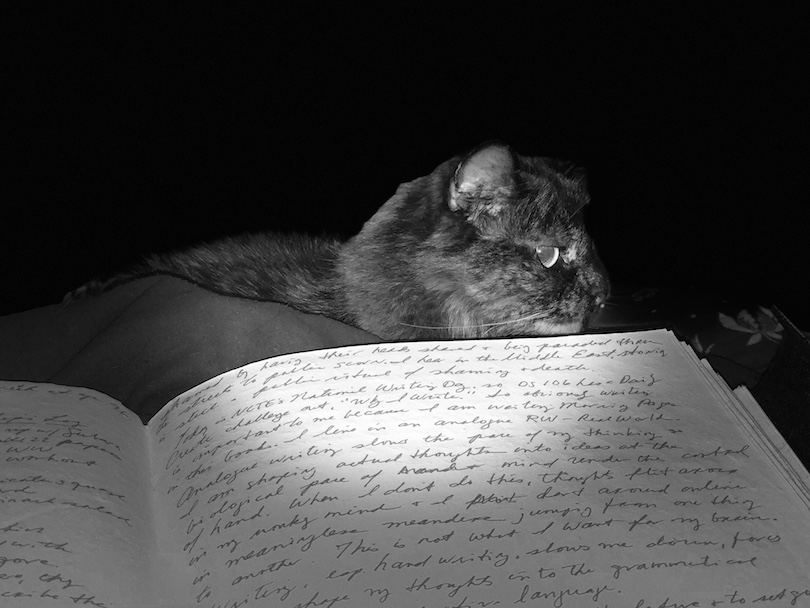Analyzing the photograph, what does the cat’s positioning on the text signify in relation to the overall composition? The cat's positioning atop the pages of text reinforces themes of intimacy and curiosity. Cats are known for their inquisitive nature, and placing it on a book in the photograph could suggest a metaphorical link between curiosity and knowledge. The close-up positioning leading to an almost tactile interaction with the text engages viewers more deeply, suggesting a scene caught in a private, contemplative moment, where the pages perhaps symbolize the realm of human knowledge that the cat guards or contemplates. 